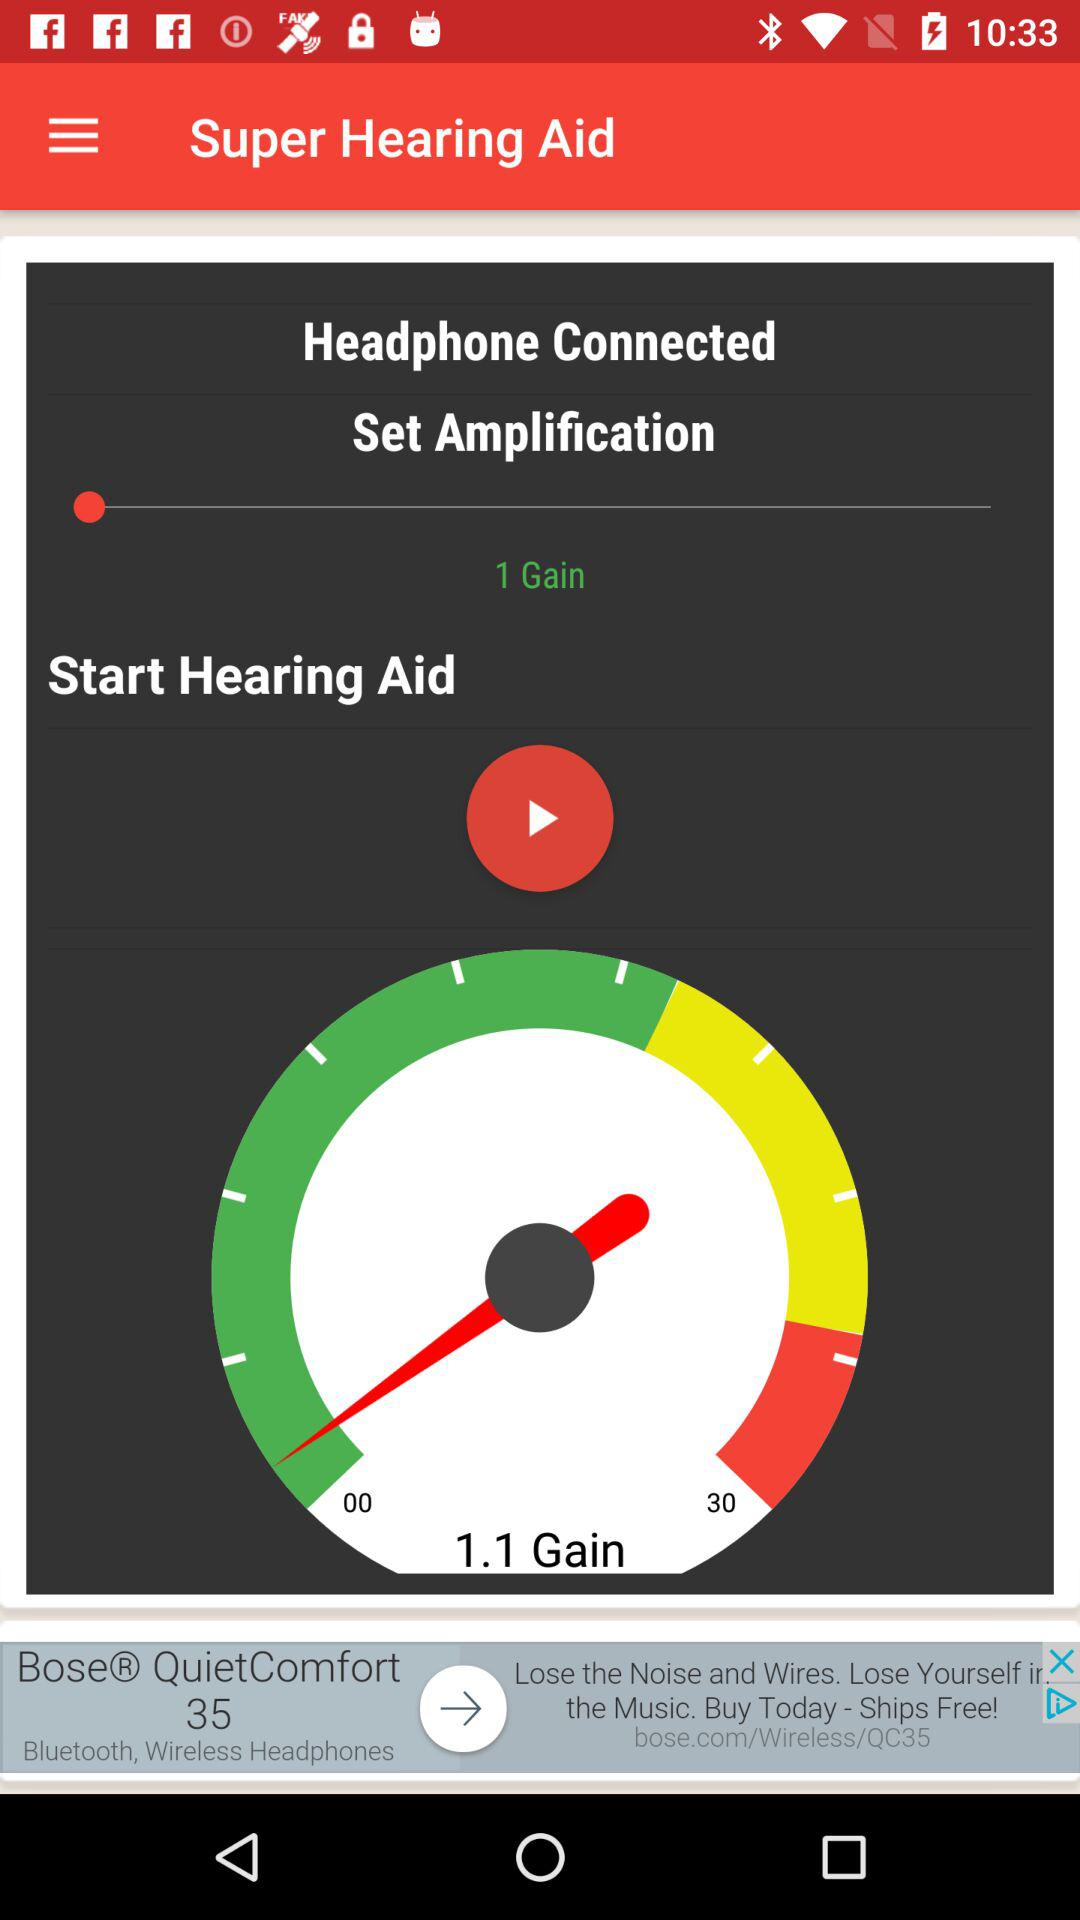What is the count of gain shown on the meter? The count of gains is 1.1. 